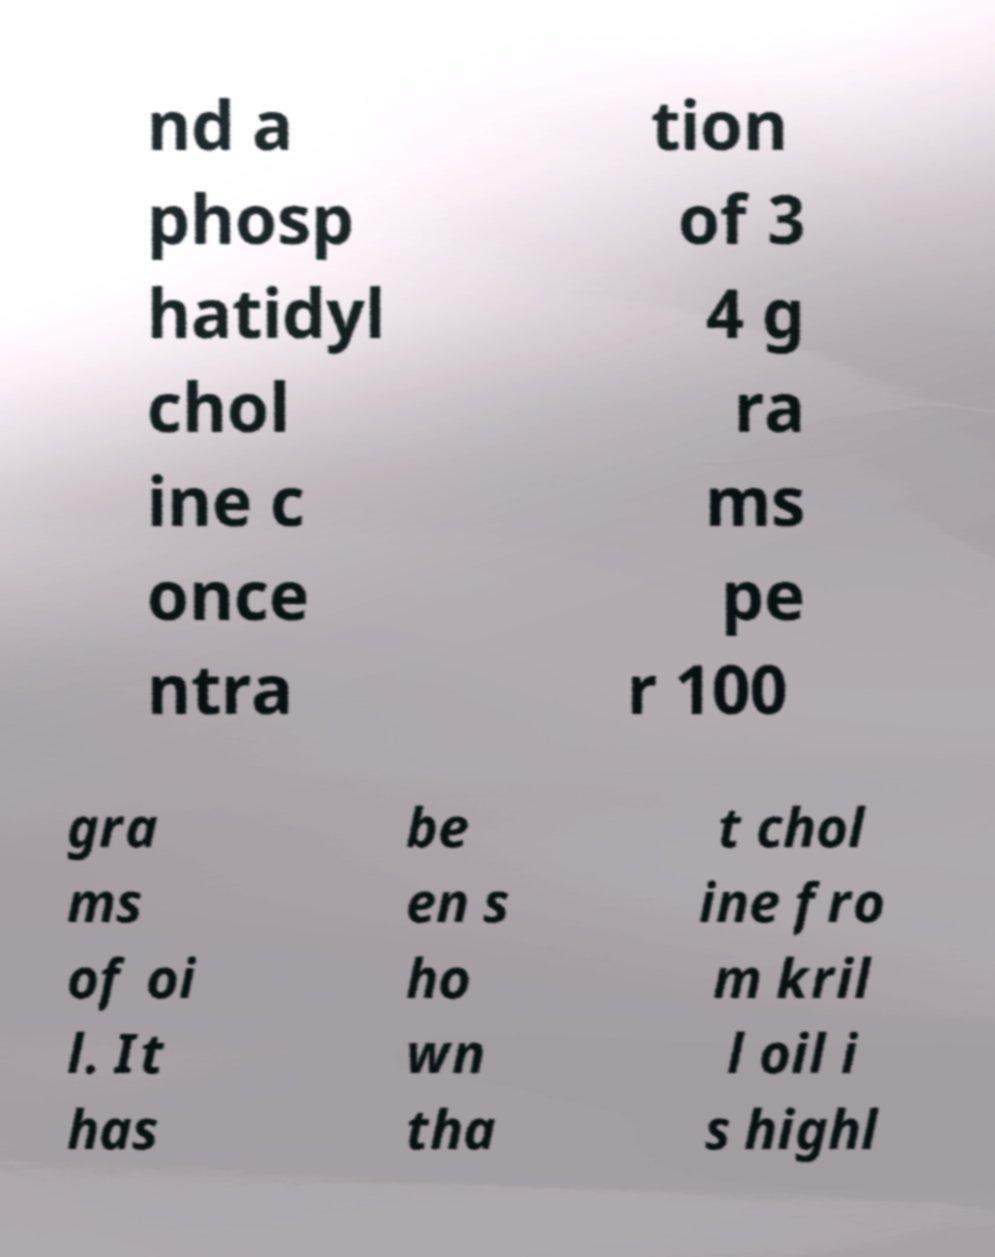Could you assist in decoding the text presented in this image and type it out clearly? nd a phosp hatidyl chol ine c once ntra tion of 3 4 g ra ms pe r 100 gra ms of oi l. It has be en s ho wn tha t chol ine fro m kril l oil i s highl 